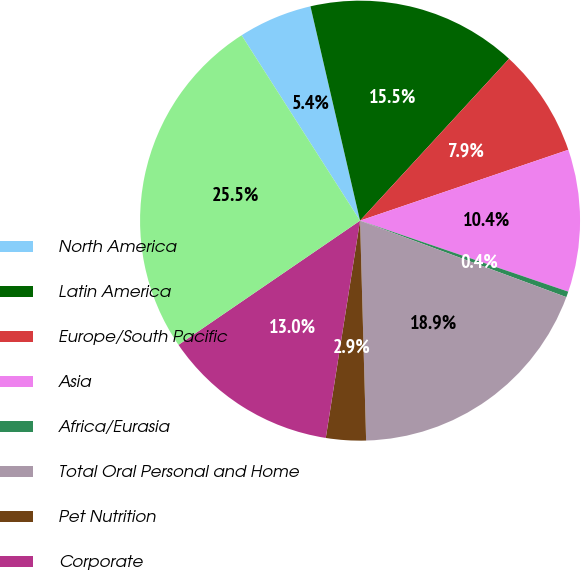Convert chart to OTSL. <chart><loc_0><loc_0><loc_500><loc_500><pie_chart><fcel>North America<fcel>Latin America<fcel>Europe/South Pacific<fcel>Asia<fcel>Africa/Eurasia<fcel>Total Oral Personal and Home<fcel>Pet Nutrition<fcel>Corporate<fcel>Total Capital expenditures<nl><fcel>5.43%<fcel>15.46%<fcel>7.94%<fcel>10.45%<fcel>0.42%<fcel>18.91%<fcel>2.93%<fcel>12.96%<fcel>25.5%<nl></chart> 